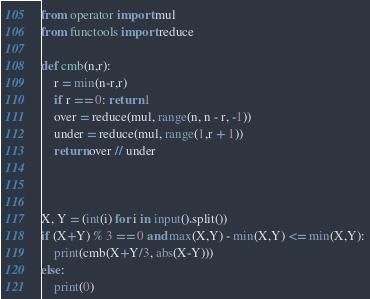Convert code to text. <code><loc_0><loc_0><loc_500><loc_500><_Python_>from operator import mul
from functools import reduce

def cmb(n,r):
    r = min(n-r,r)
    if r == 0: return 1
    over = reduce(mul, range(n, n - r, -1))
    under = reduce(mul, range(1,r + 1))
    return over // under



X, Y = (int(i) for i in input().split())
if (X+Y) % 3 == 0 and max(X,Y) - min(X,Y) <= min(X,Y):
    print(cmb(X+Y/3, abs(X-Y)))
else:
    print(0)</code> 